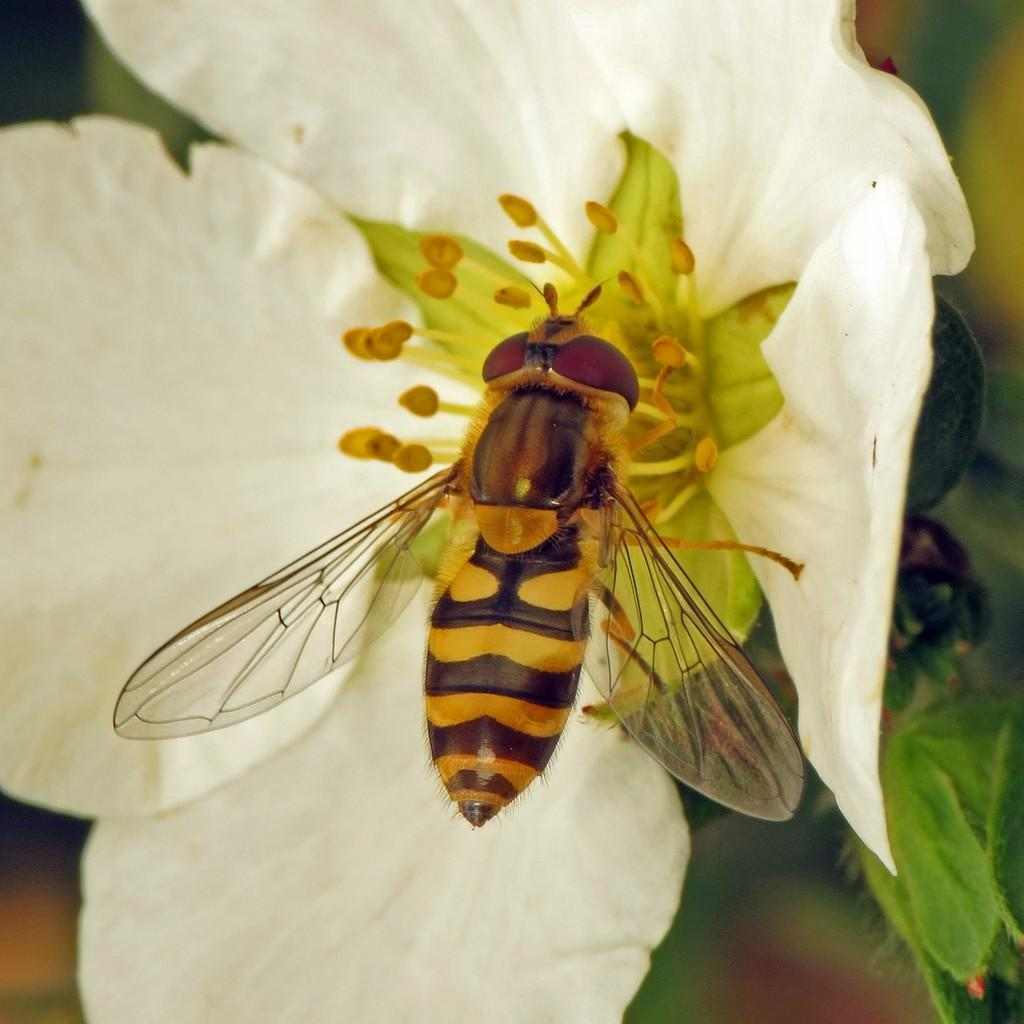What is present in the image? There is a fly in the image. Where is the fly located? The fly is on a flower. What is the fly's annual income in the image? Flies do not have an income, so this question cannot be answered. 